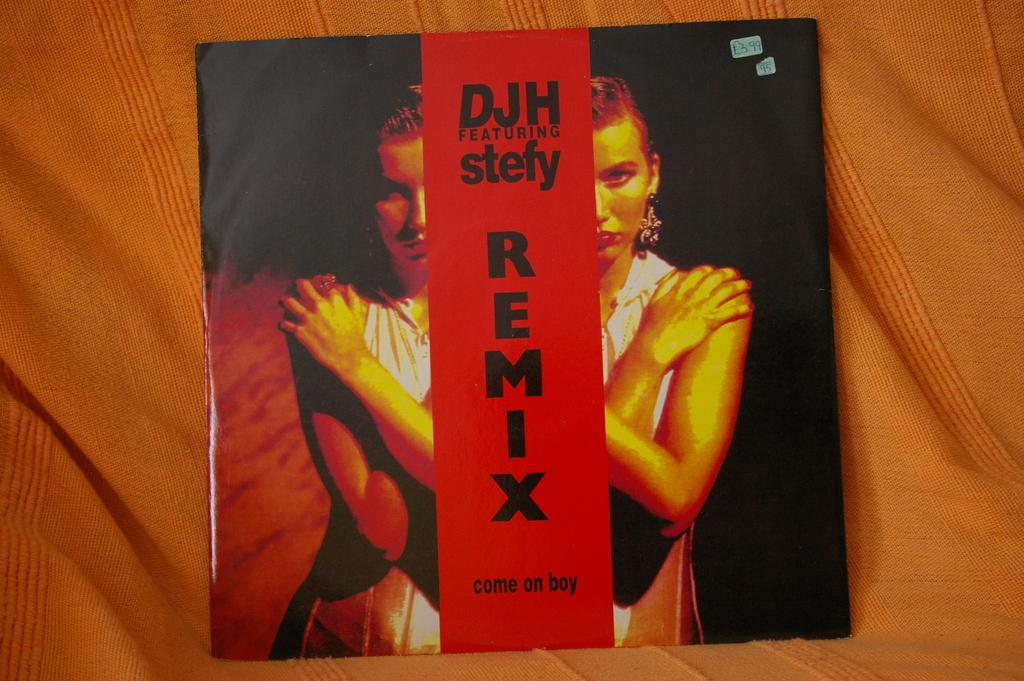What is the main subject in the center of the image? There is a book in the center of the image. What can be seen on the cover of the book? The book has a depiction of a woman. What else can be found on the book besides the image? There is text on the book. What type of material is visible in the background of the image? There is cloth visible in the background of the image. What type of powder is being mined in the background of the image? There is no reference to mining or powder in the image; it features a book with a woman's depiction and text. 